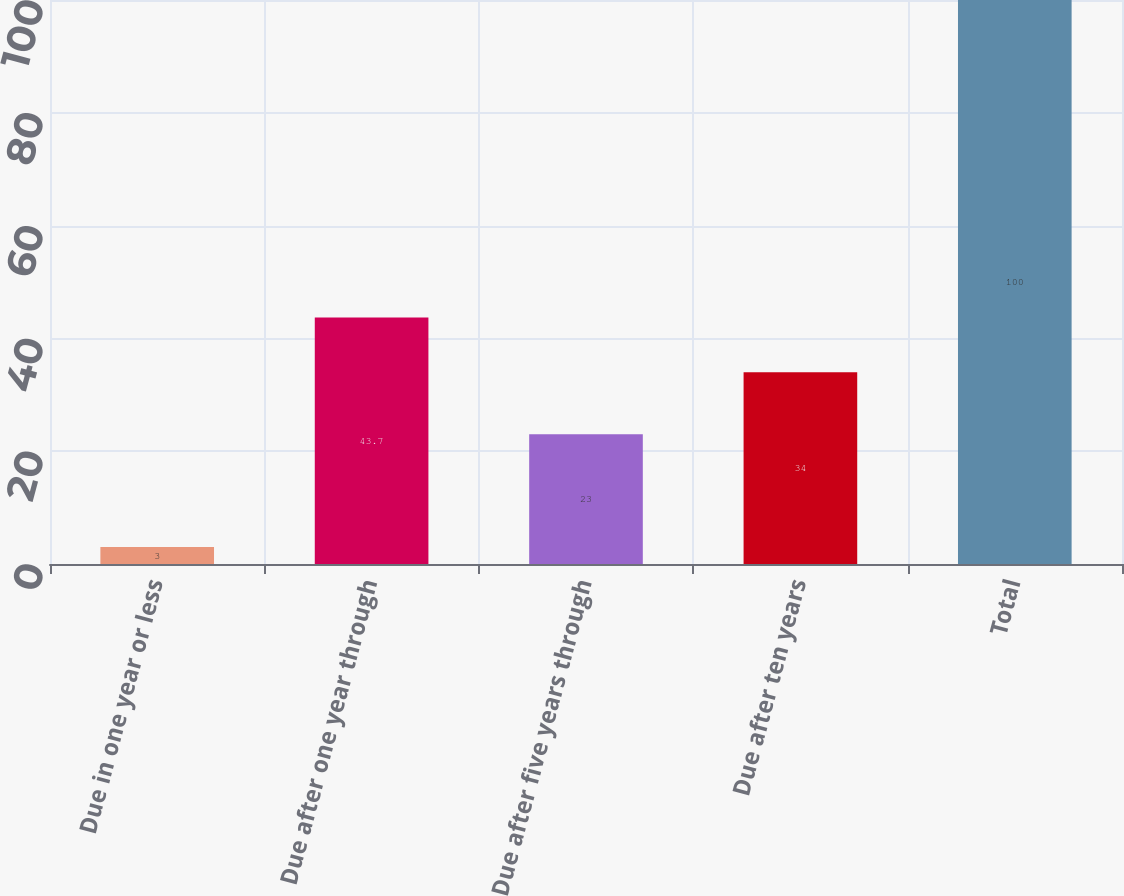Convert chart to OTSL. <chart><loc_0><loc_0><loc_500><loc_500><bar_chart><fcel>Due in one year or less<fcel>Due after one year through<fcel>Due after five years through<fcel>Due after ten years<fcel>Total<nl><fcel>3<fcel>43.7<fcel>23<fcel>34<fcel>100<nl></chart> 